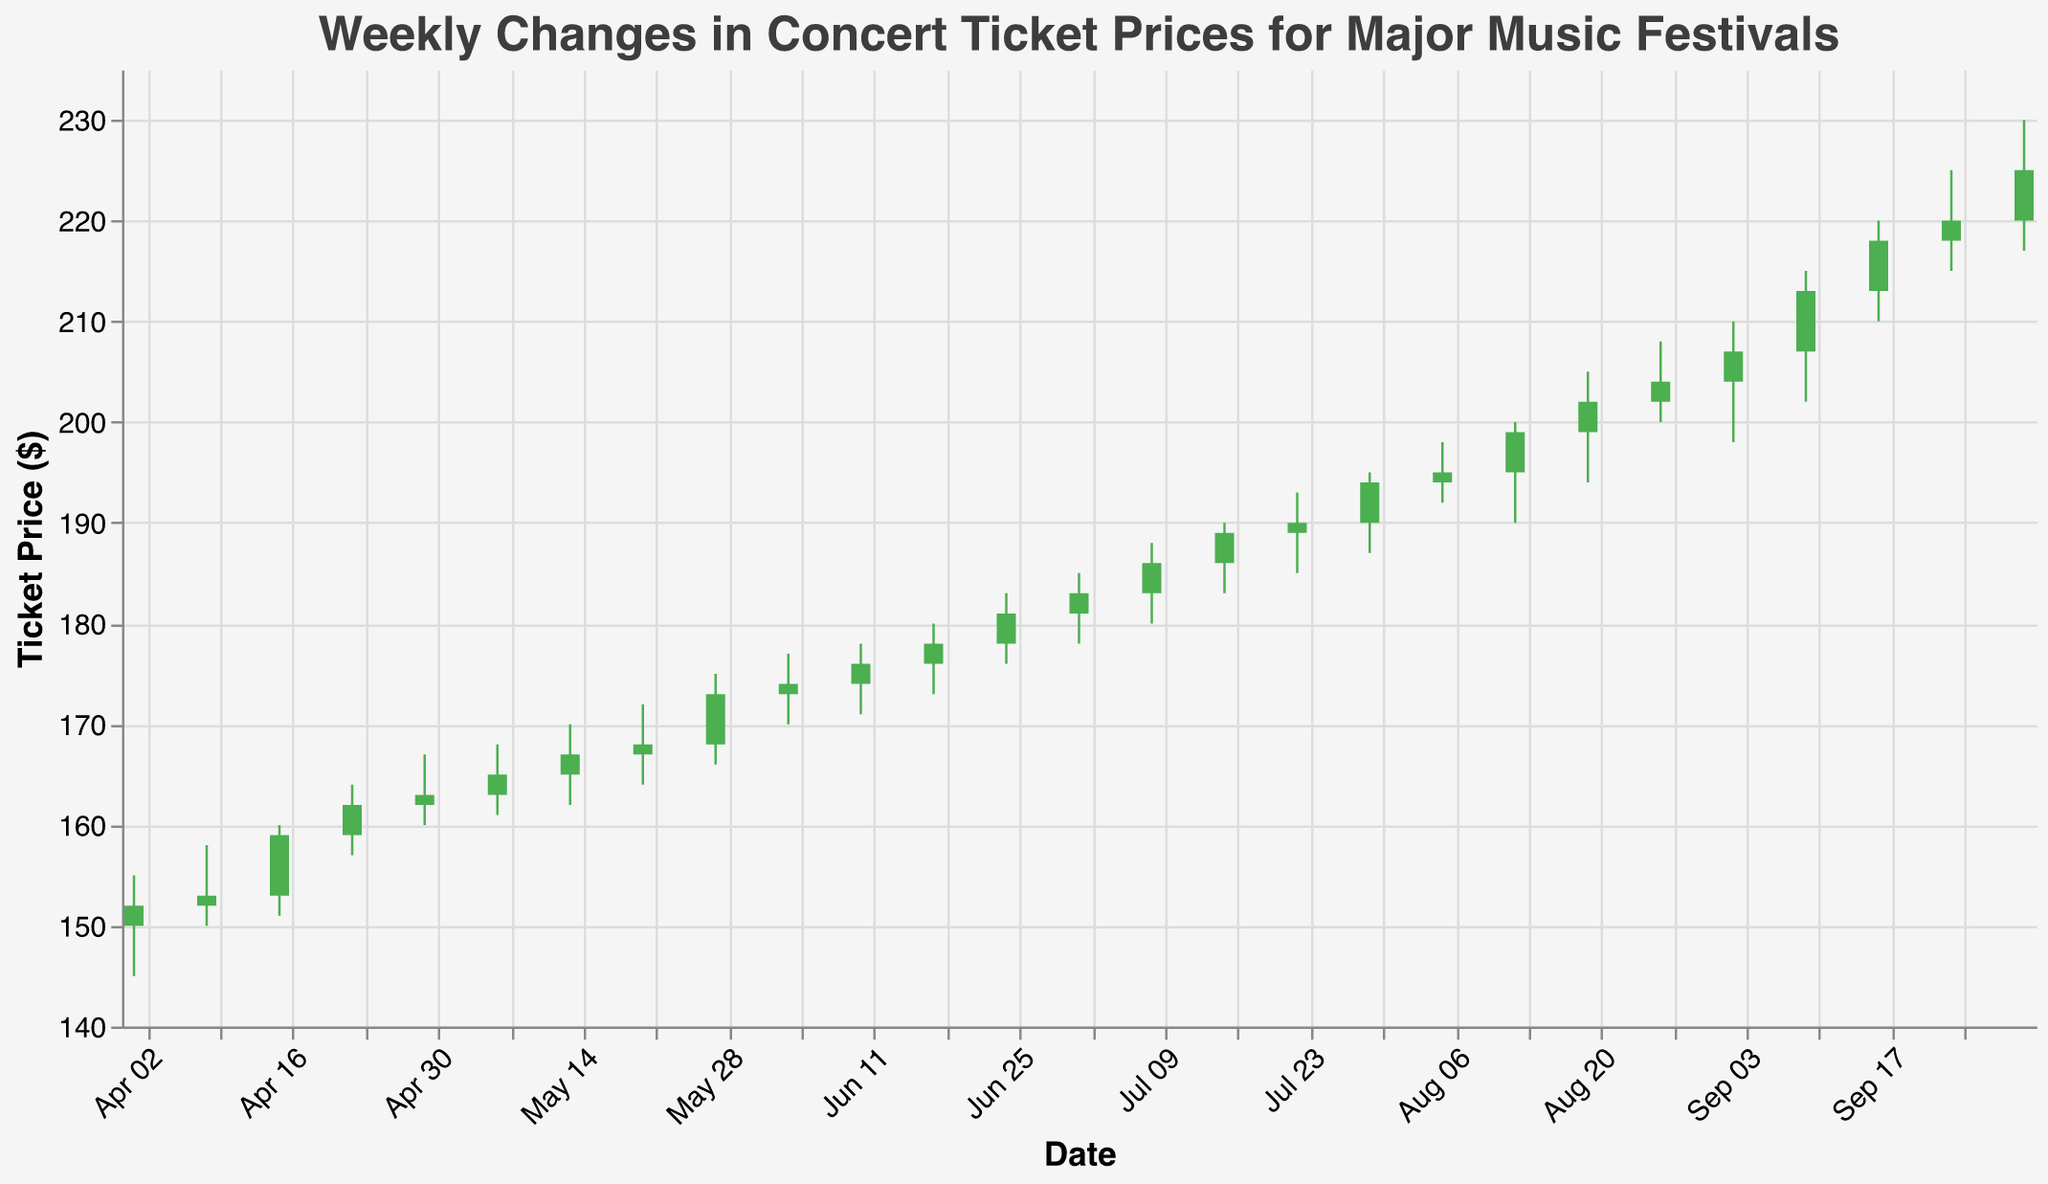What is the title of the figure? The title is generally located at the top of the figure. In this case, we can refer to the provided code that states the title.
Answer: Weekly Changes in Concert Ticket Prices for Major Music Festivals What is the price range visible on the y-axis? The y-axis range is determined by the set domain in the plot configuration. According to the provided code, the y-axis ranges from 140 to 235 dollars.
Answer: 140 - 235 dollars Which week had the highest closing ticket price for Sziget? Identify the data points for Sziget and compare their closing prices. For Sziget, the dates are 2023-08-05 (195), 2023-08-12 (199), and 2023-08-19 (202). The highest closing price is on 2023-08-19 with a closing price of 202 dollars.
Answer: 2023-08-19 (202 dollars) During which music festival did the ticket prices fall the most in a single week? Look for the week with the highest difference between the open and close prices where the close is lower than the open. The biggest drop happened during Burning Man from 2023-09-02 when the price dropped from 204 to 207.
Answer: Burning Man (2023-09-02) Which Music Festival shows a consistent increase in ticket prices over its duration? Analyze the closing prices for each week of each music festival. Coachella shows a consistent increase: 152 on 2023-04-01, 153 on 2023-04-08, and 159 on 2023-04-15.
Answer: Coachella What is the percentage change in ticket price at Glastonbury from the start to the end of its festival period? Calculate the percentage change from the opening price on the first day to the closing price on the last day. For Glastonbury: Opening price on 2023-05-13 is 165 and closing price on 2023-05-27 is 173. The percentage change is ((173-165)/165)*100 ≈ 4.85%.
Answer: 4.85% How many Music Festivals are represented in the figure? The number of unique festivals is evident by looking at the 'Music Festival' entries in the data. We see Coachella, Bonnaroo, Glastonbury, Lollapalooza, Roskilde, Tomorrowland, Sziget, Burning Man, and Reading Festival. That makes 9 unique festivals.
Answer: 9 Which week had the highest high price over the entire period? Examine the 'High' values across all weeks. The highest high value is 230 on 2023-09-30 for the Reading Festival.
Answer: 2023-09-30 (230 dollars) What is the overall trend in ticket prices over six months? Observe the general direction of the closing prices from the first week to the last week. The data shows an upward overall trend, as prices start at 152 and end at 225.
Answer: Upward trend 